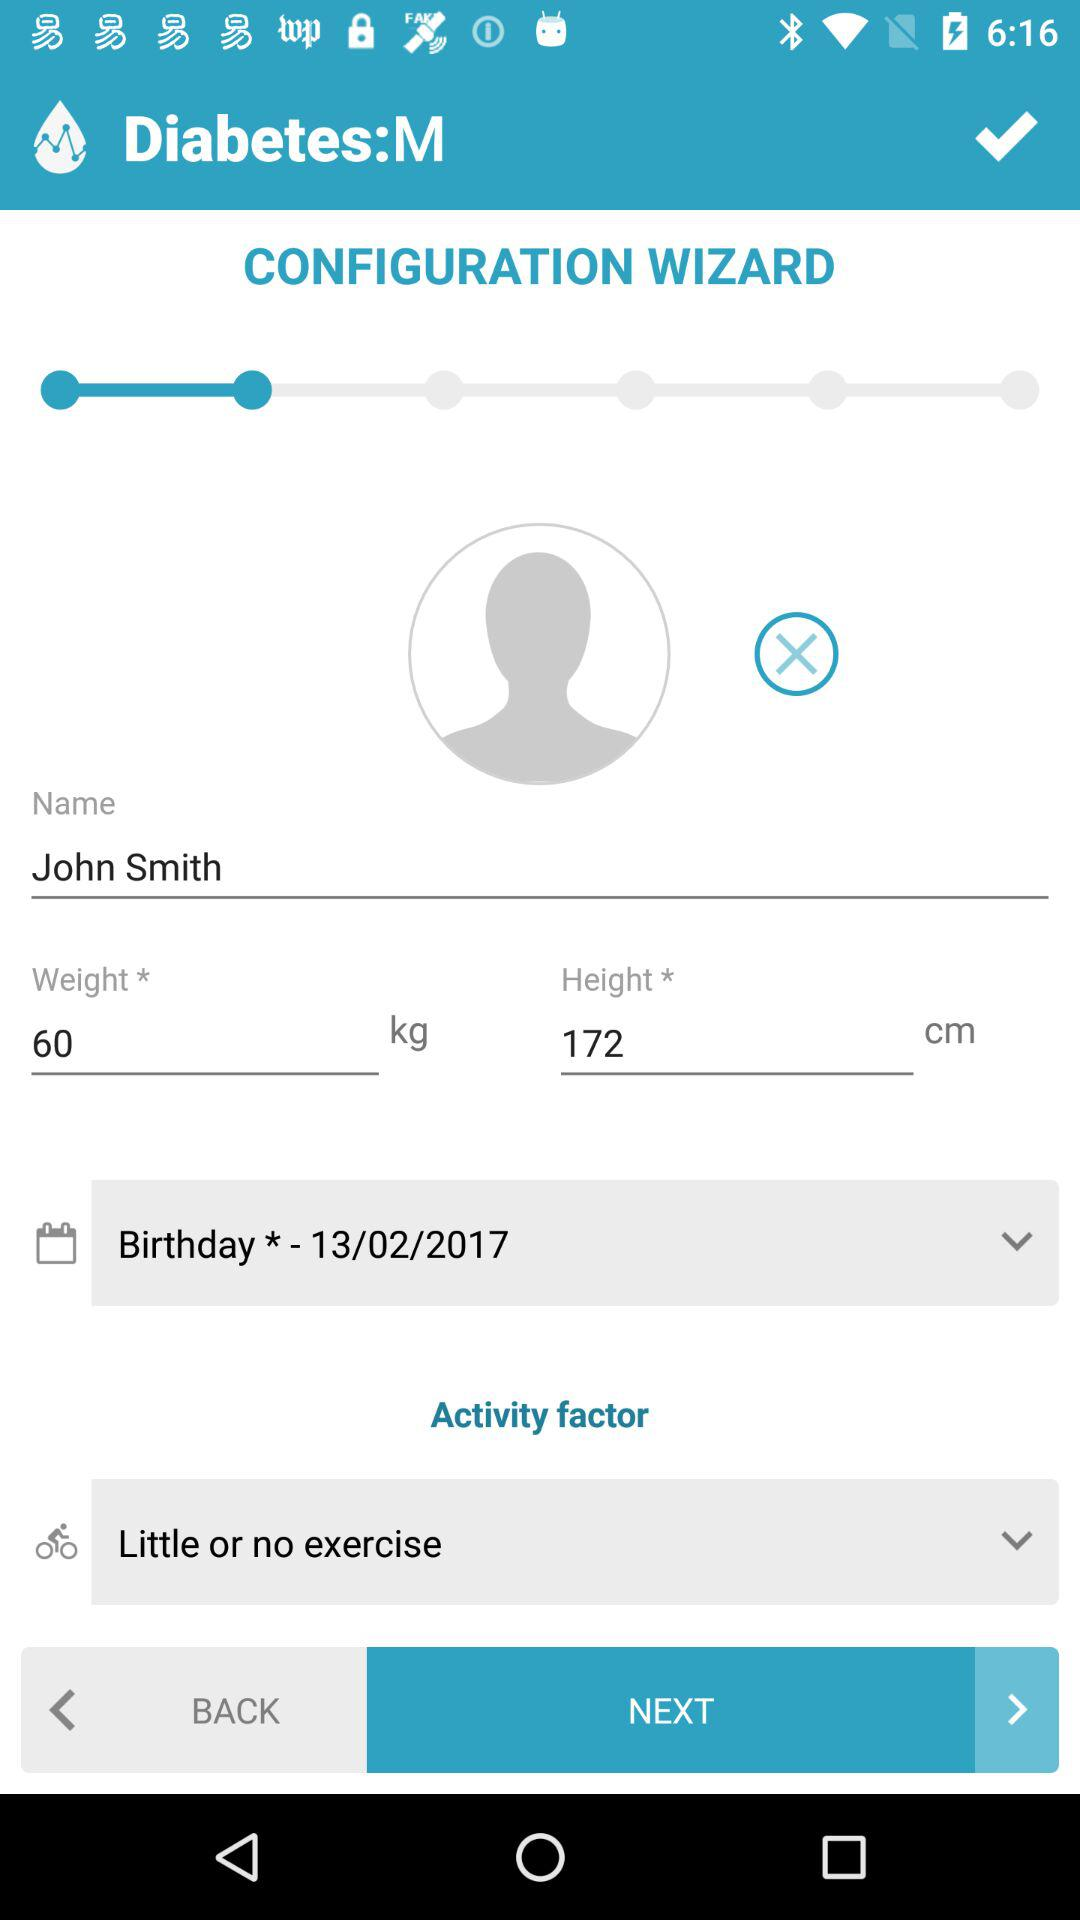What is the name? The name is "John Smith". 